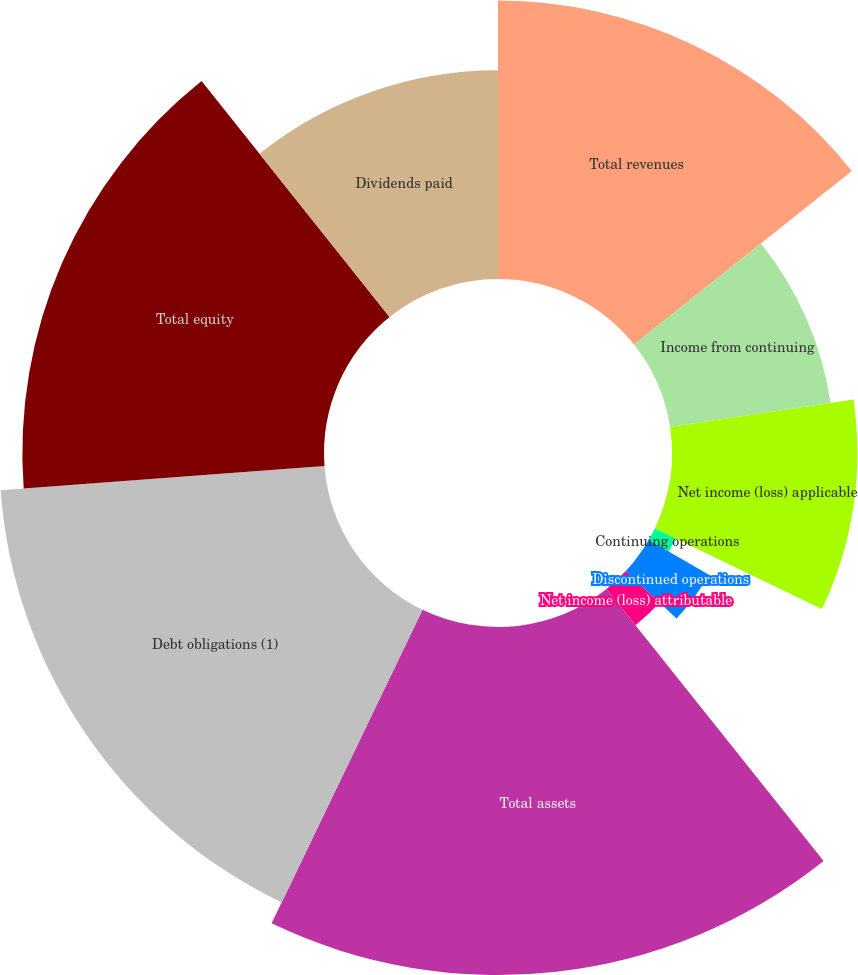Convert chart. <chart><loc_0><loc_0><loc_500><loc_500><pie_chart><fcel>Total revenues<fcel>Income from continuing<fcel>Net income (loss) applicable<fcel>Continuing operations<fcel>Discontinued operations<fcel>Net income (loss) attributable<fcel>Total assets<fcel>Debt obligations (1)<fcel>Total equity<fcel>Dividends paid<nl><fcel>14.29%<fcel>8.33%<fcel>9.52%<fcel>1.19%<fcel>3.57%<fcel>2.38%<fcel>17.86%<fcel>16.67%<fcel>15.48%<fcel>10.71%<nl></chart> 